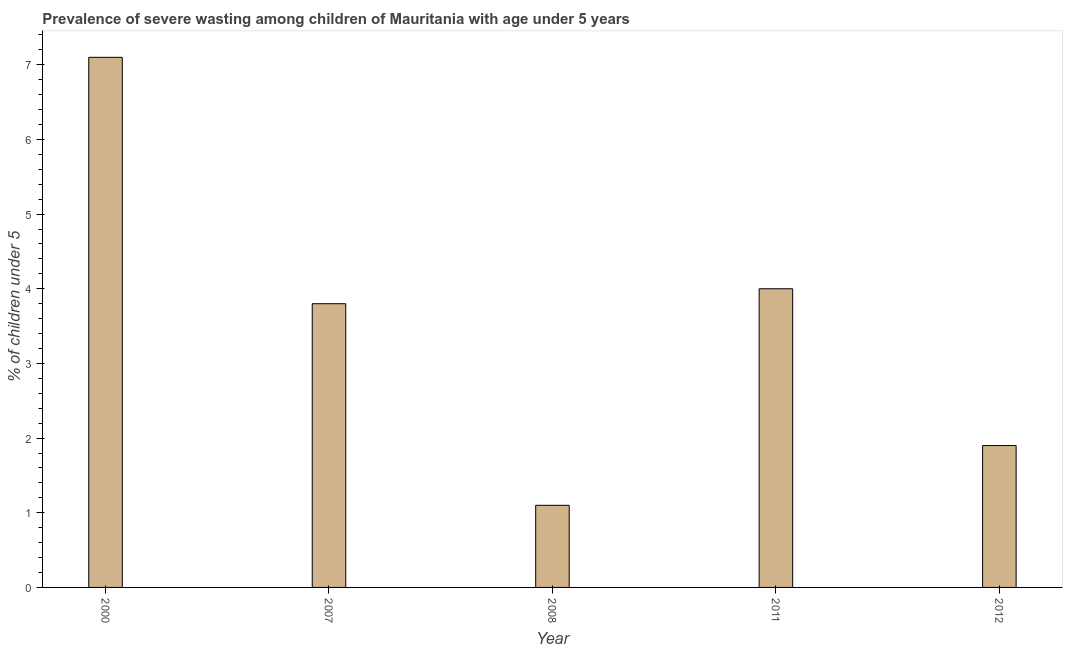Does the graph contain any zero values?
Make the answer very short. No. What is the title of the graph?
Make the answer very short. Prevalence of severe wasting among children of Mauritania with age under 5 years. What is the label or title of the X-axis?
Offer a very short reply. Year. What is the label or title of the Y-axis?
Provide a succinct answer.  % of children under 5. What is the prevalence of severe wasting in 2012?
Provide a succinct answer. 1.9. Across all years, what is the maximum prevalence of severe wasting?
Your response must be concise. 7.1. Across all years, what is the minimum prevalence of severe wasting?
Keep it short and to the point. 1.1. In which year was the prevalence of severe wasting maximum?
Keep it short and to the point. 2000. In which year was the prevalence of severe wasting minimum?
Give a very brief answer. 2008. What is the sum of the prevalence of severe wasting?
Your answer should be very brief. 17.9. What is the difference between the prevalence of severe wasting in 2000 and 2011?
Ensure brevity in your answer.  3.1. What is the average prevalence of severe wasting per year?
Offer a very short reply. 3.58. What is the median prevalence of severe wasting?
Your answer should be very brief. 3.8. What is the ratio of the prevalence of severe wasting in 2000 to that in 2011?
Your answer should be compact. 1.77. What is the difference between the highest and the second highest prevalence of severe wasting?
Offer a very short reply. 3.1. What is the difference between the highest and the lowest prevalence of severe wasting?
Make the answer very short. 6. Are all the bars in the graph horizontal?
Offer a terse response. No. How many years are there in the graph?
Your answer should be very brief. 5. What is the difference between two consecutive major ticks on the Y-axis?
Your answer should be compact. 1. What is the  % of children under 5 in 2000?
Ensure brevity in your answer.  7.1. What is the  % of children under 5 in 2007?
Your answer should be very brief. 3.8. What is the  % of children under 5 of 2008?
Your response must be concise. 1.1. What is the  % of children under 5 of 2012?
Offer a very short reply. 1.9. What is the difference between the  % of children under 5 in 2000 and 2007?
Give a very brief answer. 3.3. What is the difference between the  % of children under 5 in 2000 and 2008?
Provide a short and direct response. 6. What is the difference between the  % of children under 5 in 2000 and 2011?
Your answer should be compact. 3.1. What is the difference between the  % of children under 5 in 2000 and 2012?
Offer a very short reply. 5.2. What is the difference between the  % of children under 5 in 2007 and 2008?
Make the answer very short. 2.7. What is the difference between the  % of children under 5 in 2007 and 2012?
Make the answer very short. 1.9. What is the ratio of the  % of children under 5 in 2000 to that in 2007?
Provide a short and direct response. 1.87. What is the ratio of the  % of children under 5 in 2000 to that in 2008?
Offer a terse response. 6.46. What is the ratio of the  % of children under 5 in 2000 to that in 2011?
Provide a short and direct response. 1.77. What is the ratio of the  % of children under 5 in 2000 to that in 2012?
Give a very brief answer. 3.74. What is the ratio of the  % of children under 5 in 2007 to that in 2008?
Provide a short and direct response. 3.46. What is the ratio of the  % of children under 5 in 2008 to that in 2011?
Make the answer very short. 0.28. What is the ratio of the  % of children under 5 in 2008 to that in 2012?
Your answer should be very brief. 0.58. What is the ratio of the  % of children under 5 in 2011 to that in 2012?
Offer a very short reply. 2.1. 